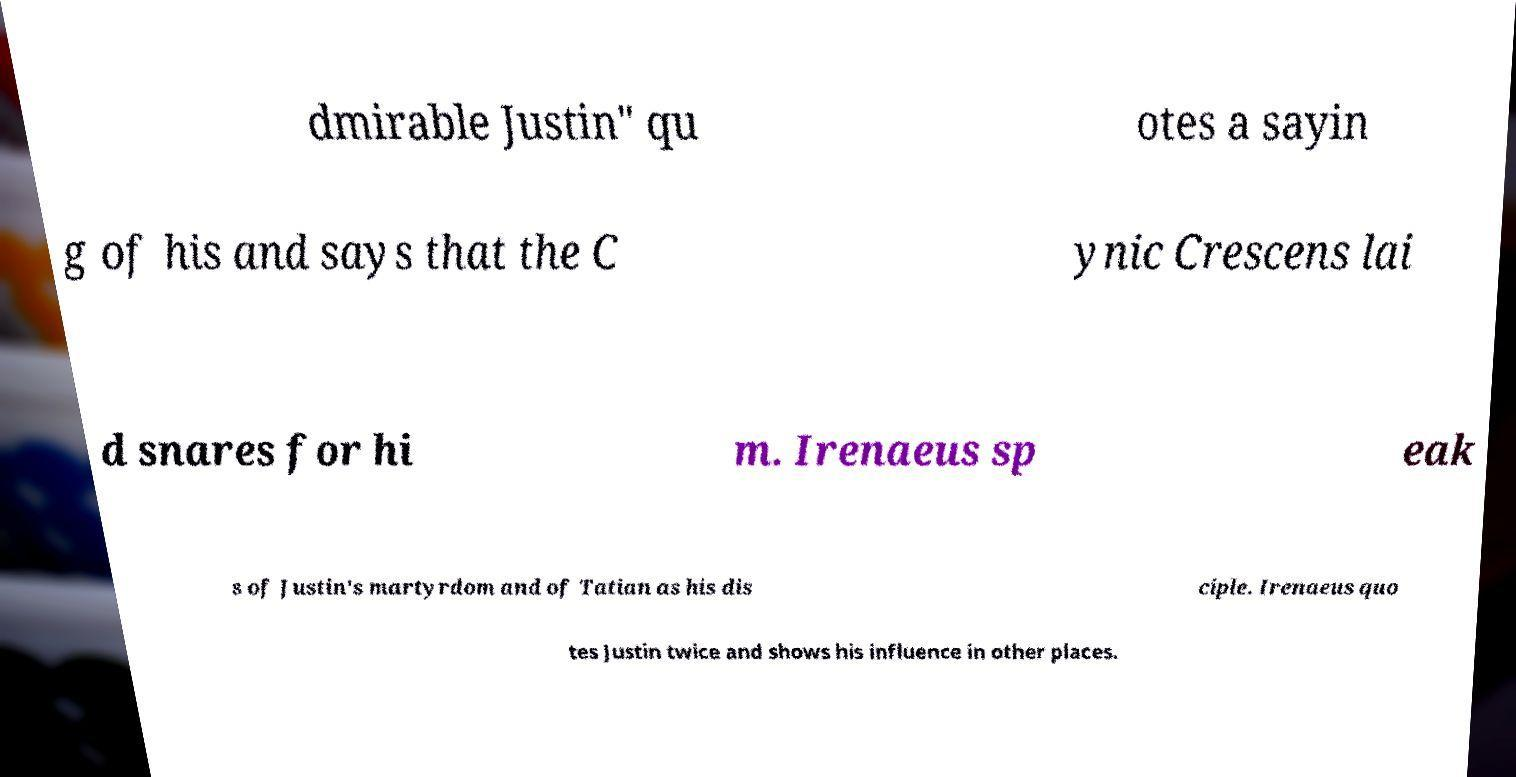There's text embedded in this image that I need extracted. Can you transcribe it verbatim? dmirable Justin" qu otes a sayin g of his and says that the C ynic Crescens lai d snares for hi m. Irenaeus sp eak s of Justin's martyrdom and of Tatian as his dis ciple. Irenaeus quo tes Justin twice and shows his influence in other places. 